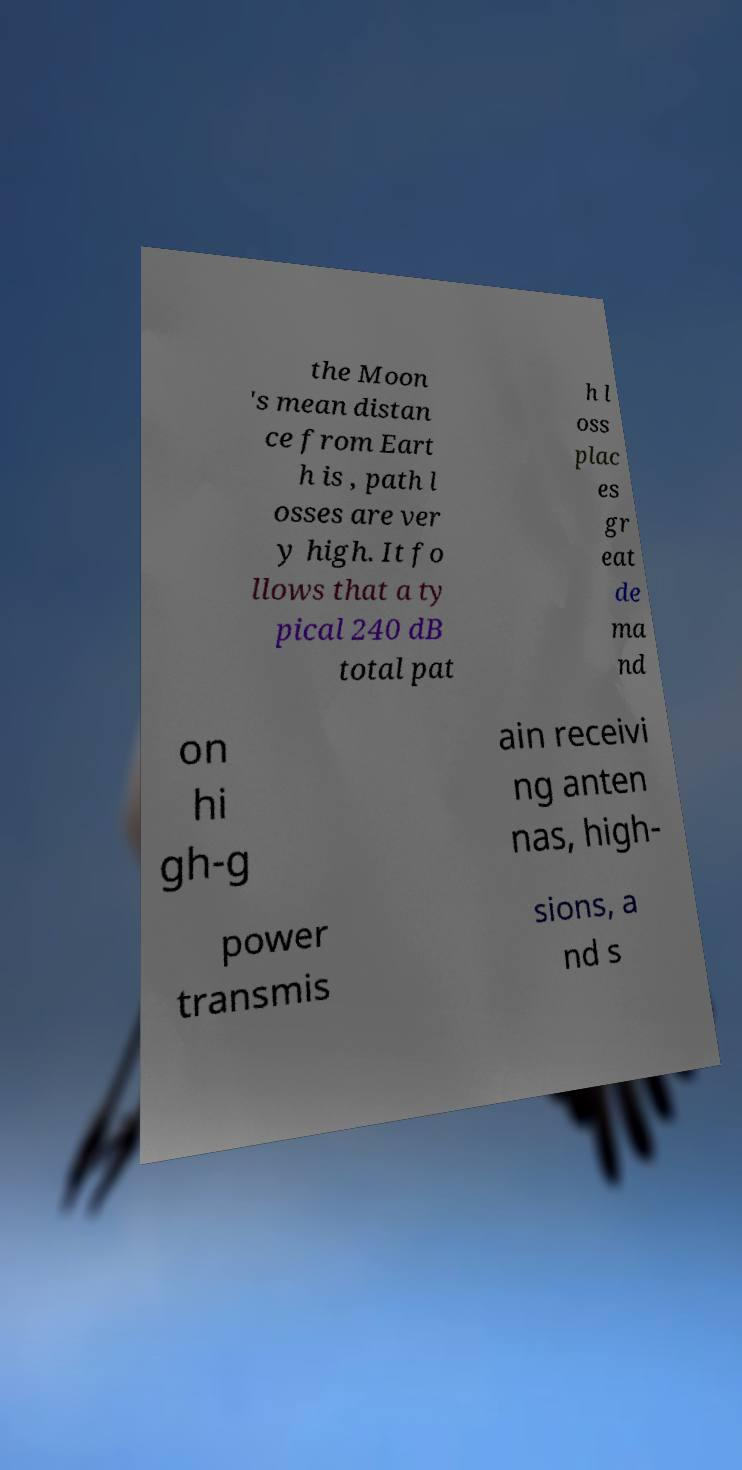Please read and relay the text visible in this image. What does it say? the Moon 's mean distan ce from Eart h is , path l osses are ver y high. It fo llows that a ty pical 240 dB total pat h l oss plac es gr eat de ma nd on hi gh-g ain receivi ng anten nas, high- power transmis sions, a nd s 